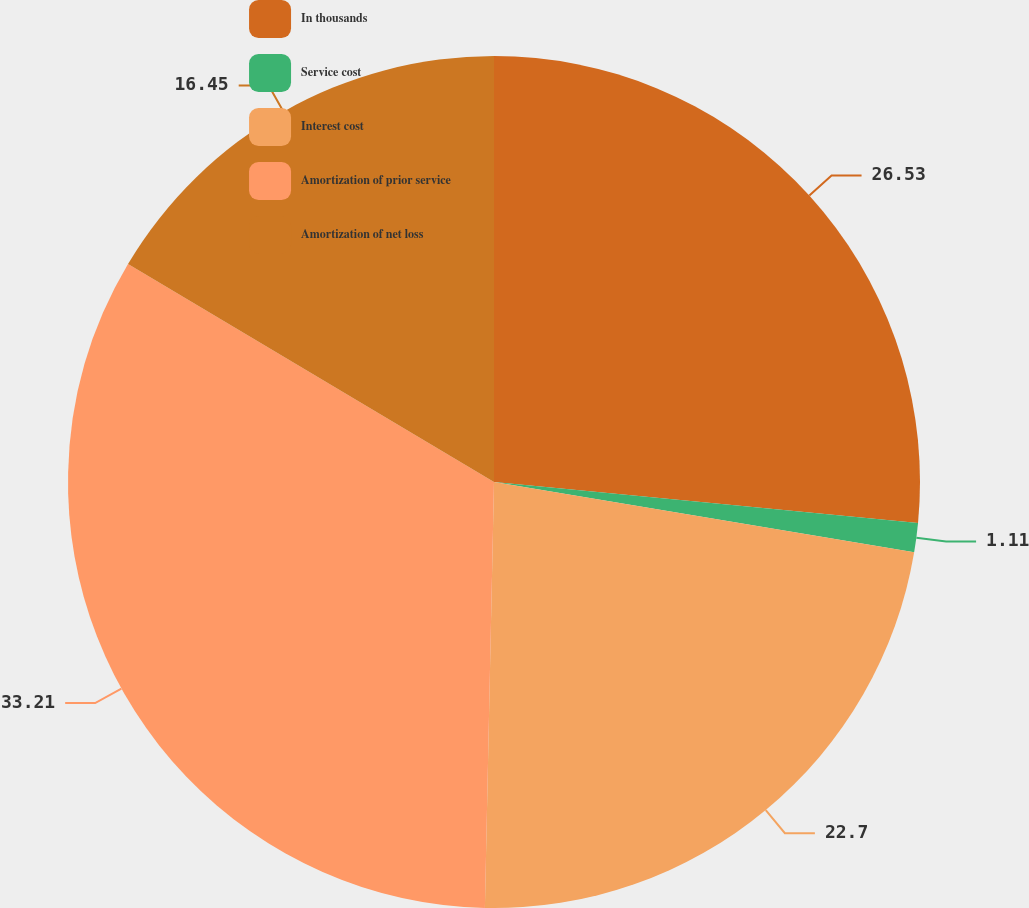Convert chart to OTSL. <chart><loc_0><loc_0><loc_500><loc_500><pie_chart><fcel>In thousands<fcel>Service cost<fcel>Interest cost<fcel>Amortization of prior service<fcel>Amortization of net loss<nl><fcel>26.53%<fcel>1.11%<fcel>22.7%<fcel>33.21%<fcel>16.45%<nl></chart> 